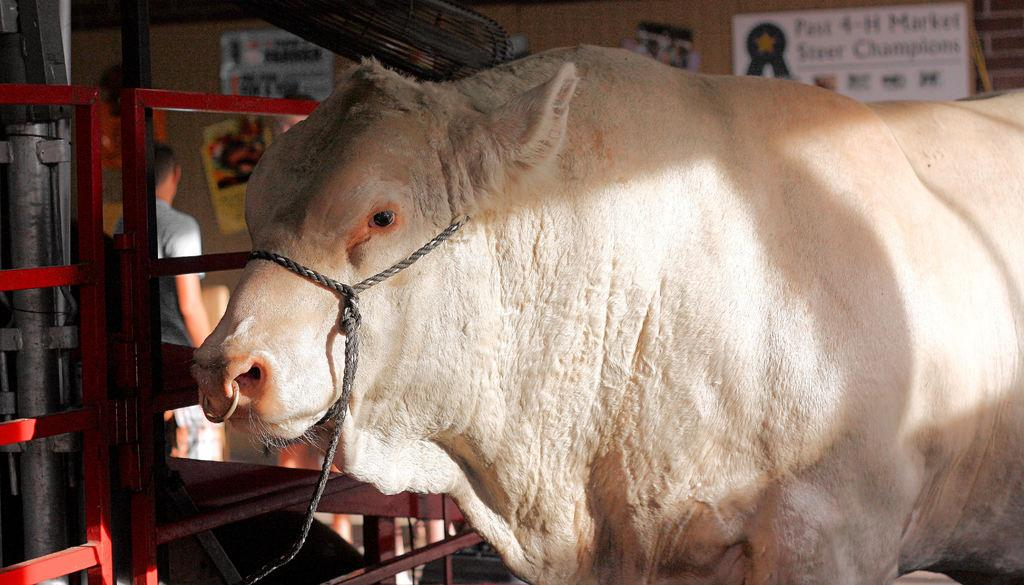What type of animal is in the image? The type of animal cannot be determined from the provided facts. What is located beside the animal in the image? There is an iron fence beside the animal in the image. Can you describe the person in the background of the image? There is a person standing in the background of the image, but their appearance cannot be determined from the provided facts. What is on the wall in the background of the image? There is a wall with posters in the background of the image. What color is the heart of the animal in the image? There is no mention of a heart or its color in the provided facts, and the animal's heart is not visible in the image. 